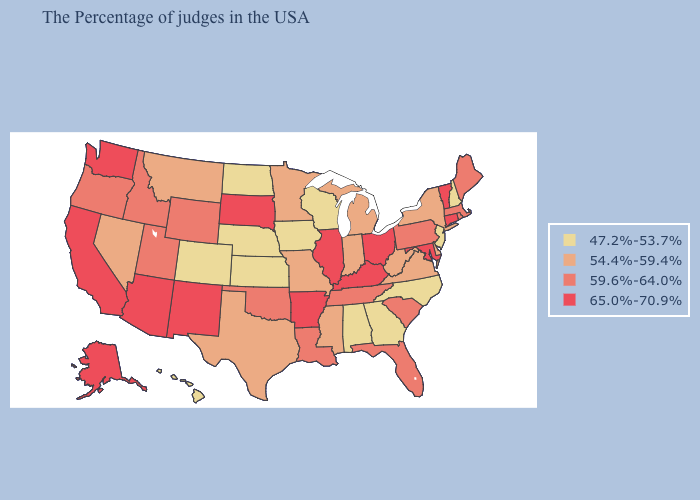What is the highest value in states that border Wisconsin?
Short answer required. 65.0%-70.9%. What is the highest value in the MidWest ?
Write a very short answer. 65.0%-70.9%. What is the value of Oregon?
Short answer required. 59.6%-64.0%. Name the states that have a value in the range 47.2%-53.7%?
Give a very brief answer. New Hampshire, New Jersey, North Carolina, Georgia, Alabama, Wisconsin, Iowa, Kansas, Nebraska, North Dakota, Colorado, Hawaii. What is the lowest value in the USA?
Short answer required. 47.2%-53.7%. Does West Virginia have the same value as Missouri?
Keep it brief. Yes. What is the value of Louisiana?
Quick response, please. 59.6%-64.0%. Does North Dakota have the lowest value in the USA?
Quick response, please. Yes. Name the states that have a value in the range 47.2%-53.7%?
Concise answer only. New Hampshire, New Jersey, North Carolina, Georgia, Alabama, Wisconsin, Iowa, Kansas, Nebraska, North Dakota, Colorado, Hawaii. Does the first symbol in the legend represent the smallest category?
Keep it brief. Yes. Does New Hampshire have the lowest value in the Northeast?
Answer briefly. Yes. Name the states that have a value in the range 59.6%-64.0%?
Answer briefly. Maine, Massachusetts, Rhode Island, Pennsylvania, South Carolina, Florida, Tennessee, Louisiana, Oklahoma, Wyoming, Utah, Idaho, Oregon. Name the states that have a value in the range 47.2%-53.7%?
Give a very brief answer. New Hampshire, New Jersey, North Carolina, Georgia, Alabama, Wisconsin, Iowa, Kansas, Nebraska, North Dakota, Colorado, Hawaii. What is the value of Massachusetts?
Keep it brief. 59.6%-64.0%. What is the lowest value in states that border Delaware?
Keep it brief. 47.2%-53.7%. 